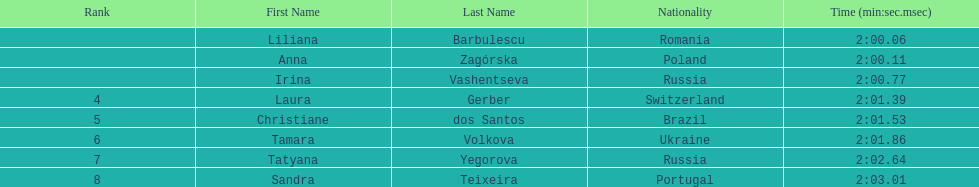What is the number of russian participants in this set of semifinals? 2. 